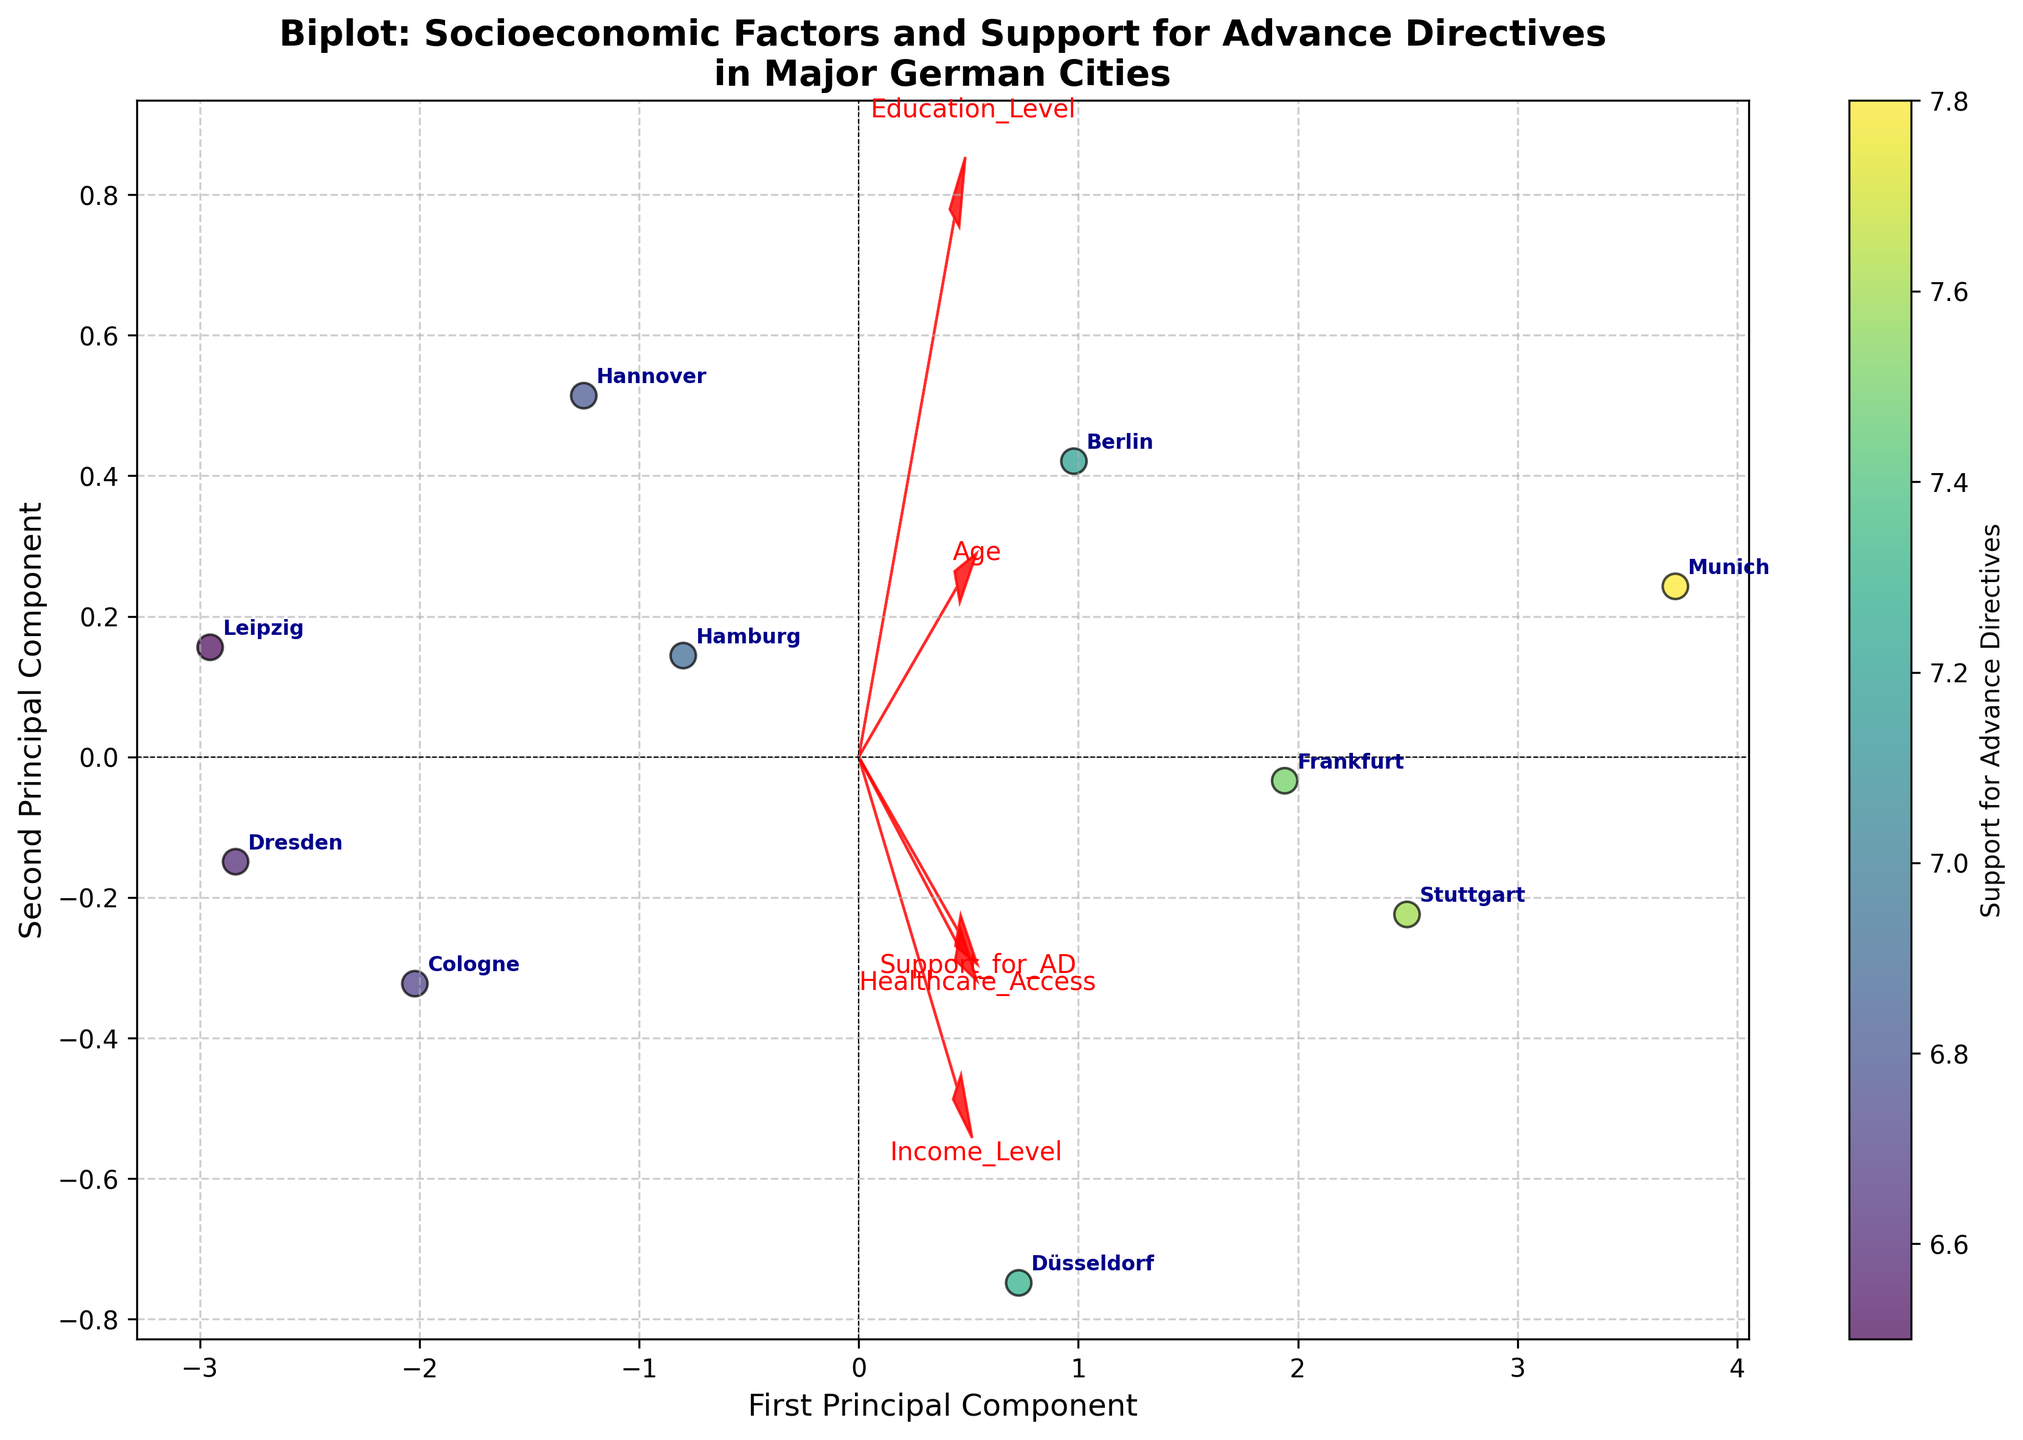Which city shows the highest support for advance directives in the plot? To determine the city with the highest support for advance directives, look for the label of the data point with the highest color intensity on the colorbar. The colorbar represents support for advance directives.
Answer: Munich Which feature vector appears the longest on the biplot? The length of the arrows in a biplot represents the variance of each feature, and a longer arrow indicates a more significant contribution to the variance.
Answer: Healthcare Access What socioeconomic factor seems to have the least influence on the first principal component? The influence on the first principal component can be assessed by looking at the length and direction of the arrows. Smaller values and almost horizontal distribution indicate less influence.
Answer: Age Based on the plot, which city has a higher support for advance directives, Frankfurt or Cologne? Compare the color intensity between the data points labeled 'Frankfurt' and 'Cologne'. The city with the higher intensity color represents higher support.
Answer: Frankfurt Is there a noticeable correlation between income level and support for advance directives based on the biplot visualization? Examine the direction and position of the 'Income_Level' and 'Support_for_AD' arrows. Strong correlations are indicated by arrows pointing in similar directions.
Answer: Yes 